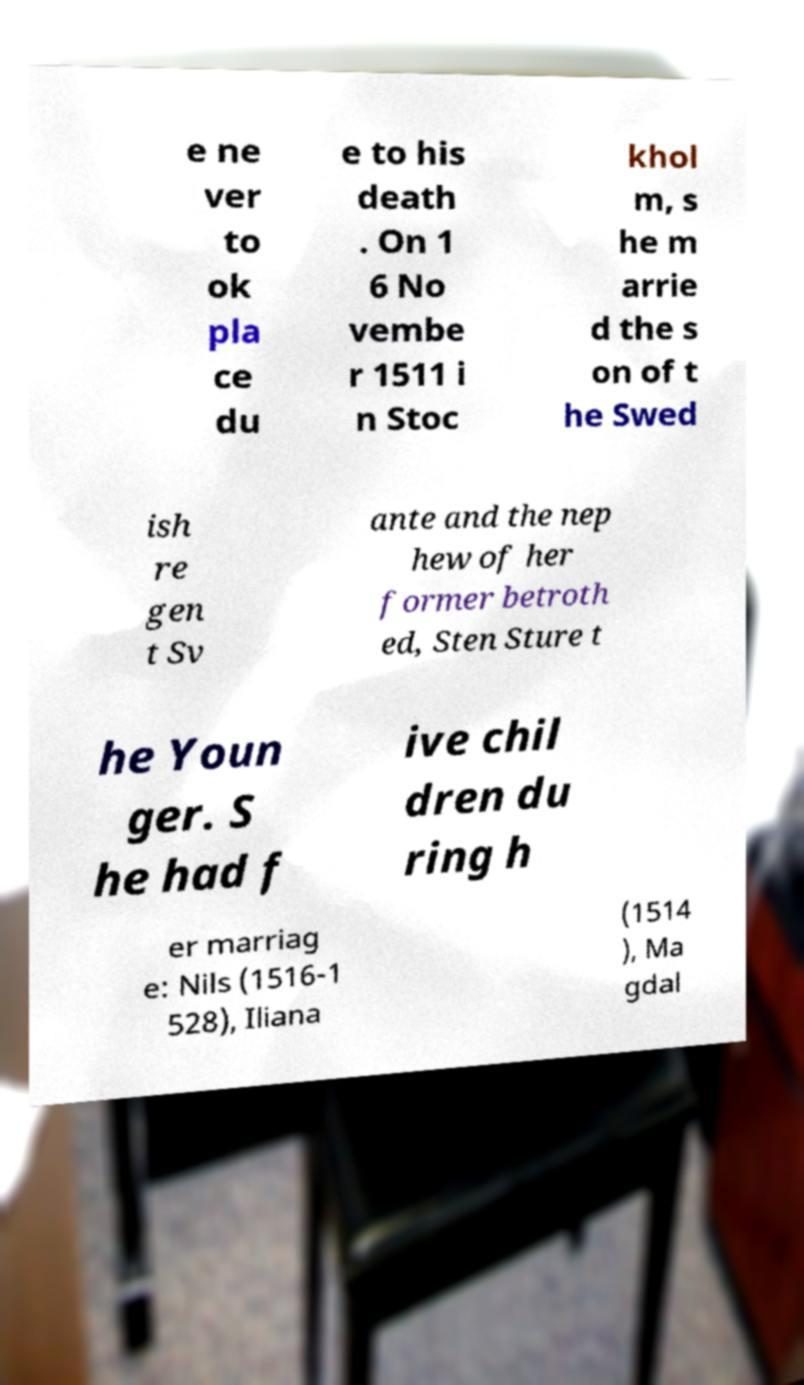Please identify and transcribe the text found in this image. e ne ver to ok pla ce du e to his death . On 1 6 No vembe r 1511 i n Stoc khol m, s he m arrie d the s on of t he Swed ish re gen t Sv ante and the nep hew of her former betroth ed, Sten Sture t he Youn ger. S he had f ive chil dren du ring h er marriag e: Nils (1516-1 528), Iliana (1514 ), Ma gdal 